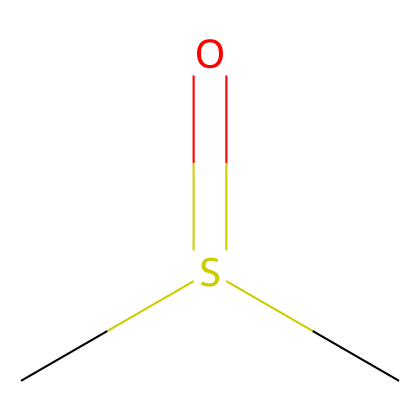How many carbon atoms are present in dimethyl sulfoxide? By examining the SMILES representation, there are two 'C' characters, indicating the presence of two carbon atoms in the structure.
Answer: 2 What is the functional group in dimethyl sulfoxide? The structure includes a sulfur atom bonded to an oxygen atom via a double bond (shown as 'S(=O)'). This indicates a sulfoxide functional group.
Answer: sulfoxide What is the oxidation state of sulfur in dimethyl sulfoxide? The sulfur atom is bonded to one sulfur atom with a double bond to oxygen and two methyl groups attached. In this context, the oxidation state of sulfur is +4.
Answer: +4 What type of bonding is present in dimethyl sulfoxide? The chemical structure includes both covalent bonds between the carbon and sulfur atoms as well as a double bond between the sulfur and oxygen, which are characteristic of organic compounds.
Answer: covalent How many oxygen atoms are in dimethyl sulfoxide? The SMILES notation shows one 'O' character, which indicates that there is one oxygen atom present in the chemical structure.
Answer: 1 What is the hybridization of the sulfur atom in dimethyl sulfoxide? The sulfur atom in this structure must accommodate four groups (two methyl groups, one double bond to oxygen, and one lone pair), indicating it has a tetrahedral arrangement, resulting in sp3 hybridization.
Answer: sp3 What type of sulfur compound is dimethyl sulfoxide classified as? DMSO is classified as a sulfoxide due to the presence of the sulfur atom bonded to an oxygen atom with a double bond, characteristic of the sulfoxide class of compounds.
Answer: sulfoxide 